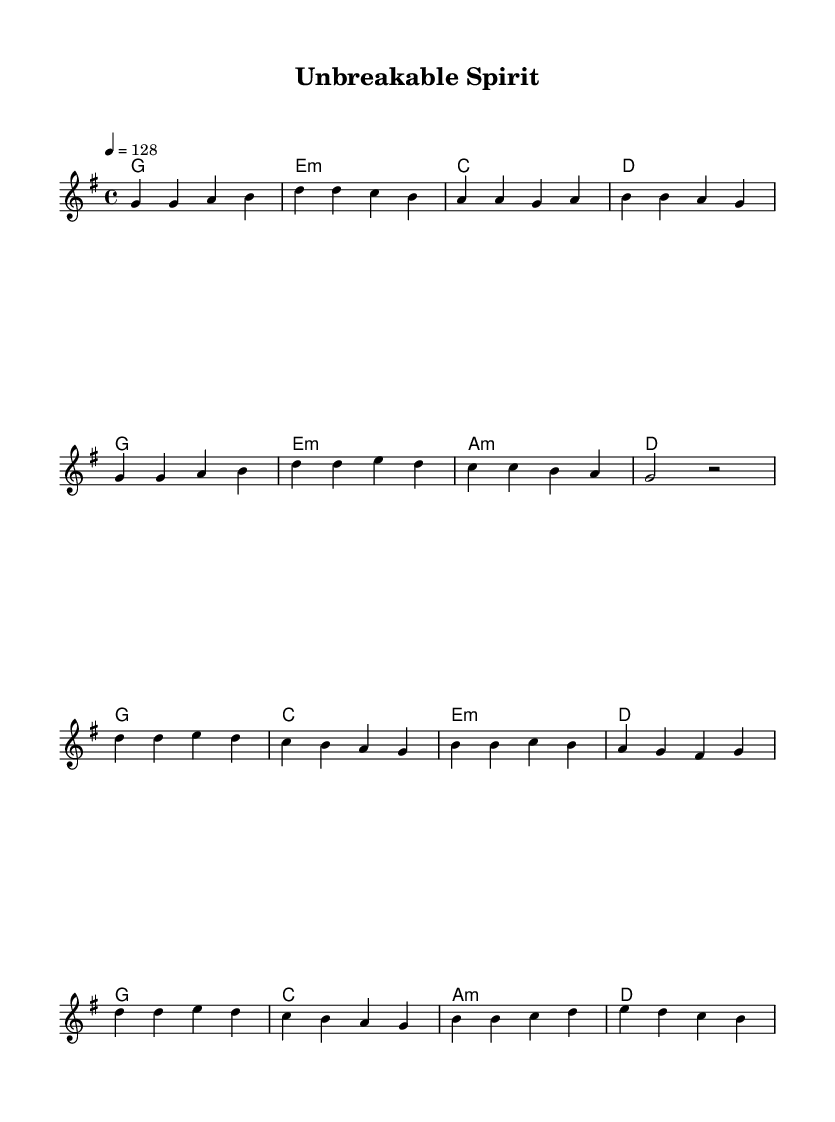What is the key signature of this music? The key signature is G major, which has one sharp (F#). It can be identified by the presence of a sharp sign on the F line in the staff.
Answer: G major What is the time signature of this piece? The time signature is 4/4, which is indicated at the beginning of the score. It means there are four beats in a measure and the quarter note gets one beat.
Answer: 4/4 What is the tempo marking for the piece? The tempo marking is 128 beats per minute, which is indicated as "4 = 128" at the beginning of the score. This indicates how fast the piece should be performed.
Answer: 128 How many measures are in the chorus section? The chorus consists of 8 measures, which can be counted by looking at the number of measure bars in the chorus section of the sheet music.
Answer: 8 What type of lyrics are featured in this K-Pop song? The lyrics feature empowering themes of self-acceptance and determination, as highlighted by phrases that emphasize personal strength and resilience.
Answer: Empowering How many different chords are used in the verse? There are 4 different chords in the verse: G, E minor, C, and D. Each chord is indicated above the melody line and corresponds with the lyrical phrases.
Answer: 4 What is the main message conveyed in the chorus? The main message of the chorus is about embracing one's journey and strength, highlighted by the repeated phrase "Unbreakable spirit." This emphasizes self-empowerment.
Answer: Embracing strength 